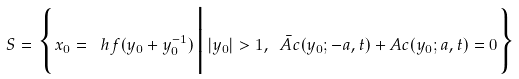<formula> <loc_0><loc_0><loc_500><loc_500>S = \Big \{ x _ { 0 } = \ h f ( y _ { 0 } + y _ { 0 } ^ { - 1 } ) \, \Big | \, | y _ { 0 } | > 1 , \ \bar { A } c ( y _ { 0 } ; - a , t ) + A c ( y _ { 0 } ; a , t ) = 0 \Big \}</formula> 